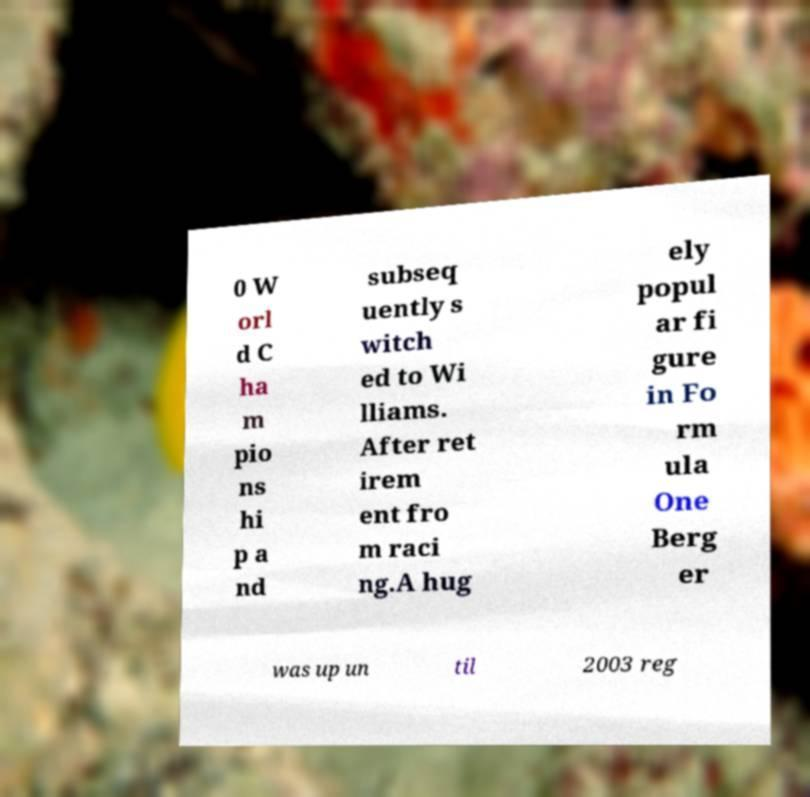Please read and relay the text visible in this image. What does it say? 0 W orl d C ha m pio ns hi p a nd subseq uently s witch ed to Wi lliams. After ret irem ent fro m raci ng.A hug ely popul ar fi gure in Fo rm ula One Berg er was up un til 2003 reg 